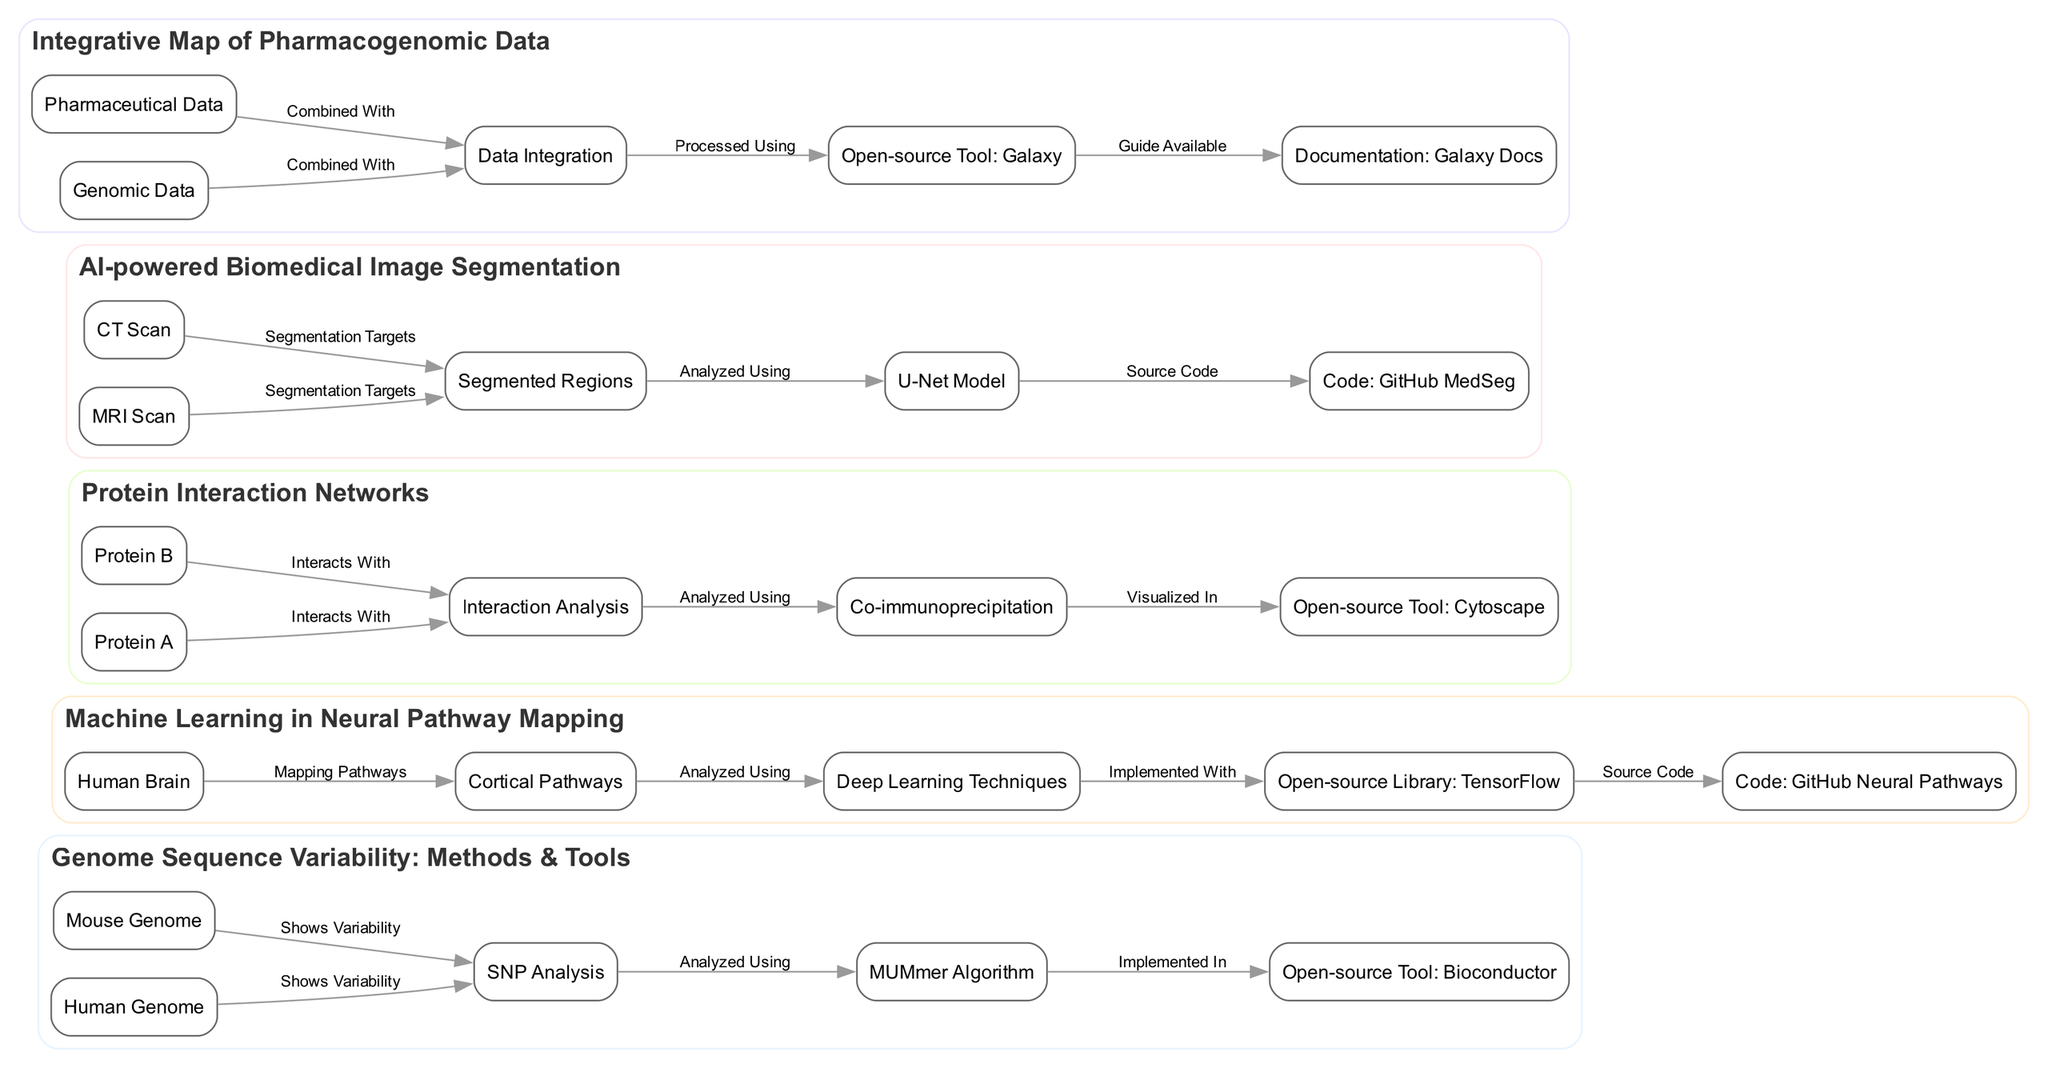What is the title of the Genome Sequence variability diagram? The title can be found at the top of the diagram, which states "Genome Sequence Variability: Methods & Tools."
Answer: Genome Sequence Variability: Methods & Tools How many nodes are present in the Neural Pathway Mapping diagram? Counting the nodes listed in the data, "Human Brain," "Cortical Pathways," "Deep Learning Techniques," "Open-source Library: TensorFlow," and "Code: GitHub Neural Pathways," we find a total of 5 nodes.
Answer: 5 Which open-source tool is associated with protein-protein interaction networks? Looking for nodes in the diagram that relate to tools, we find "Open-source Tool: Cytoscape" listed as associated with the interaction analysis.
Answer: Open-source Tool: Cytoscape What does the U-Net Model analyze in the Biomedical Image Segmentation diagram? The edge leading from "Segmented Regions" to "U-Net Model" indicates that the model is used for analyzing the segmented regions.
Answer: Segmented Regions Which two types of data are integrated in the Pharmacogenomics Data Integration diagram? The data nodes in the diagram include "Genomic Data" and "Pharmaceutical Data," which come together to undergo integration.
Answer: Genomic Data and Pharmaceutical Data How does the MUMmer Algorithm relate to the Open-source Tool in the Genome Sequence Variability diagram? The MUMmer Algorithm is analyzed using SNP Analysis, and it is implemented in the open-source tool Bioconductor, as indicated by the directed edges.
Answer: Implemented In What is the relationship between the Human Brain and Cortical Pathways in the Neural Pathway Mapping diagram? The relationship is indicated by the arrow connecting "Human Brain" to "Cortical Pathways," which defines the brain as mapping the pathways.
Answer: Mapping Pathways What is the source code repository for the AI-powered Biomedical Image Segmentation? The node labeled "Code: GitHub MedSeg" is designated as the source code for the segmentation model depicted in the diagram.
Answer: Code: GitHub MedSeg How are the various data types processed in the Pharmacogenomics Data Integration? The edge from "Data Integration" to "Open-source Tool: Galaxy" illustrates that the integrated data type is processed using the Galaxy tool.
Answer: Processed Using 